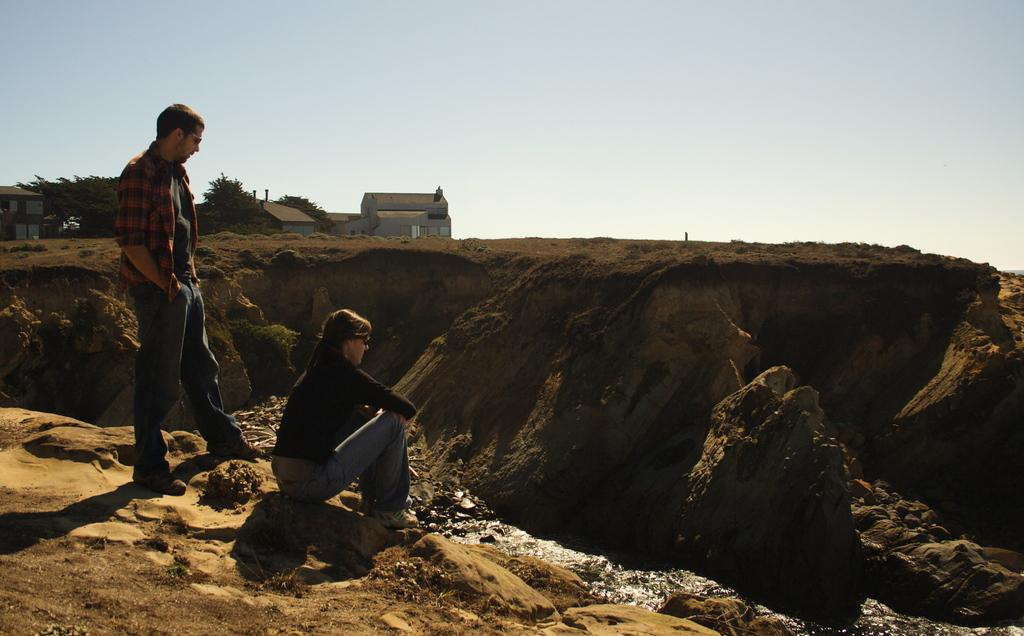What is the person in the image doing? There is a person sitting on a rock in the image. Can you describe the other person in the image? There is a man standing on the left side of the image. What can be seen in the background of the image? There are sheds, trees, rocks, and the sky visible in the background of the image. What type of art is the monkey creating on the tray in the image? There is no monkey or tray present in the image. 